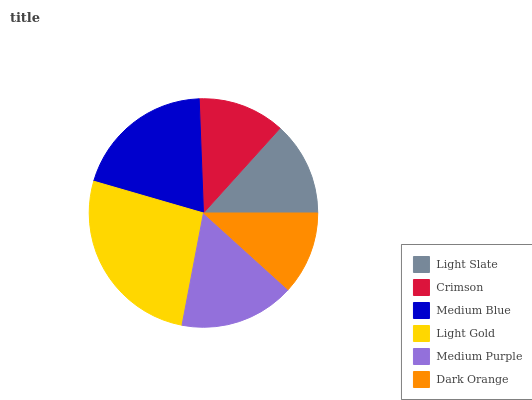Is Dark Orange the minimum?
Answer yes or no. Yes. Is Light Gold the maximum?
Answer yes or no. Yes. Is Crimson the minimum?
Answer yes or no. No. Is Crimson the maximum?
Answer yes or no. No. Is Light Slate greater than Crimson?
Answer yes or no. Yes. Is Crimson less than Light Slate?
Answer yes or no. Yes. Is Crimson greater than Light Slate?
Answer yes or no. No. Is Light Slate less than Crimson?
Answer yes or no. No. Is Medium Purple the high median?
Answer yes or no. Yes. Is Light Slate the low median?
Answer yes or no. Yes. Is Medium Blue the high median?
Answer yes or no. No. Is Medium Blue the low median?
Answer yes or no. No. 